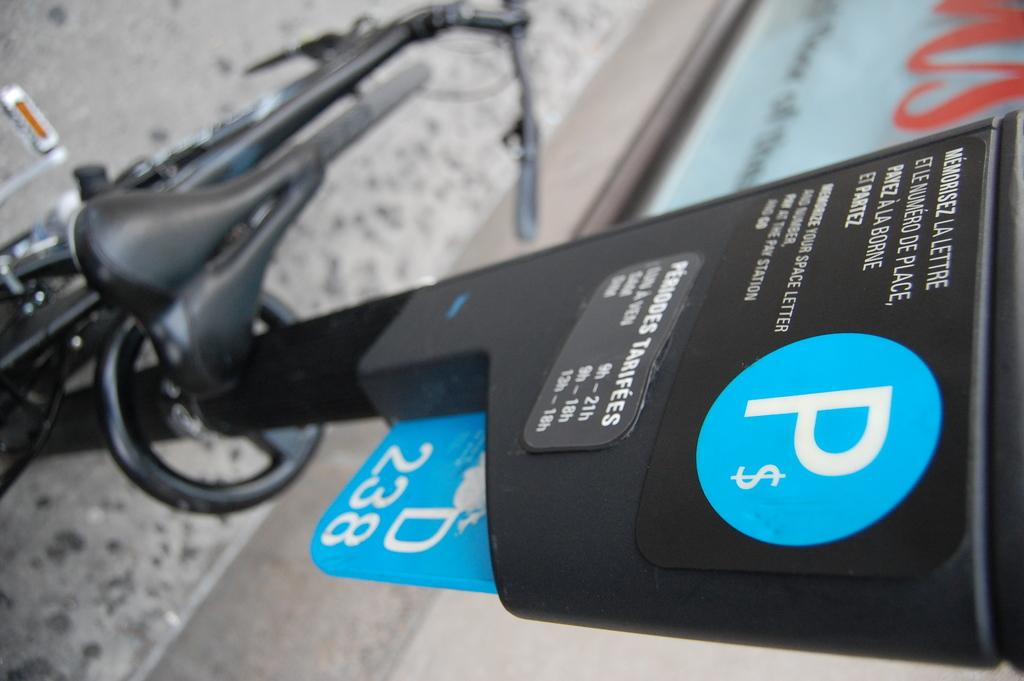What mode of transportation is visible in the image? There is a cycle in the image. Where is the cycle located? The cycle is on the ground. What object can be seen on the right side of the image? There is a parking meter on the right side of the image. What type of surface is at the bottom of the image? There is a pavement at the bottom of the image. What type of shop is visible in the image? There is no shop visible in the image; it only features a cycle, a parking meter, and a pavement. 